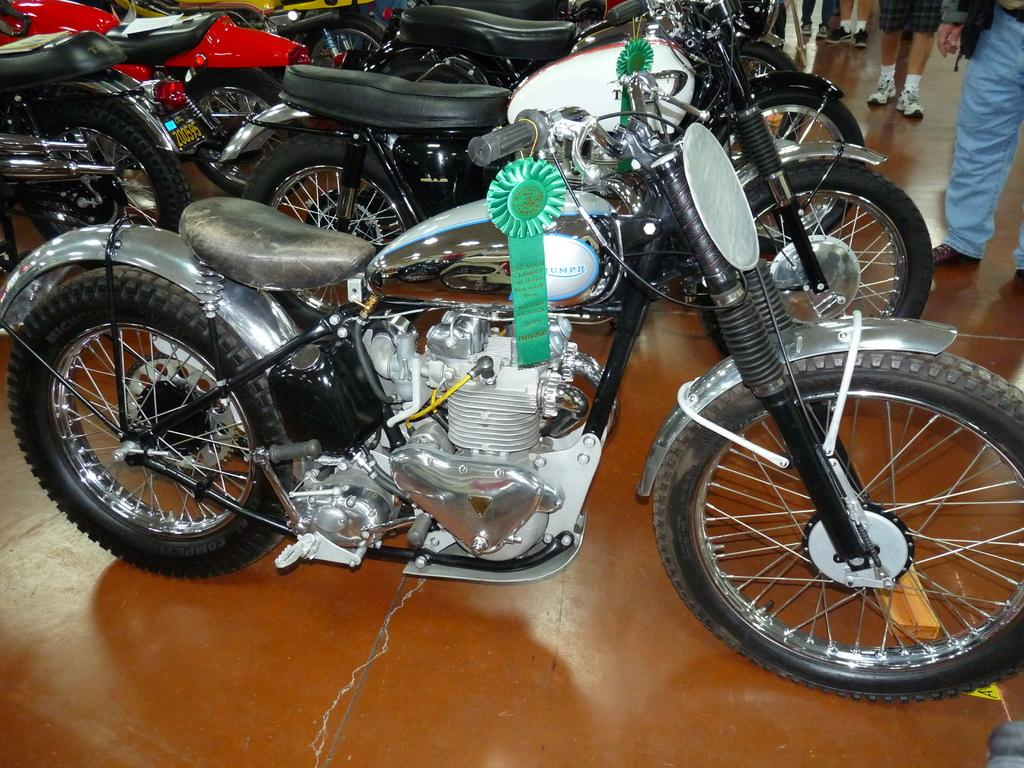How many people are in the image? There is a group of people in the image, but the exact number is not specified. What vehicles are present in the image? There are motorcycles in the image. What type of bear can be seen performing magic tricks in the image? There is no bear or magic tricks present in the image; it features a group of people and motorcycles. 